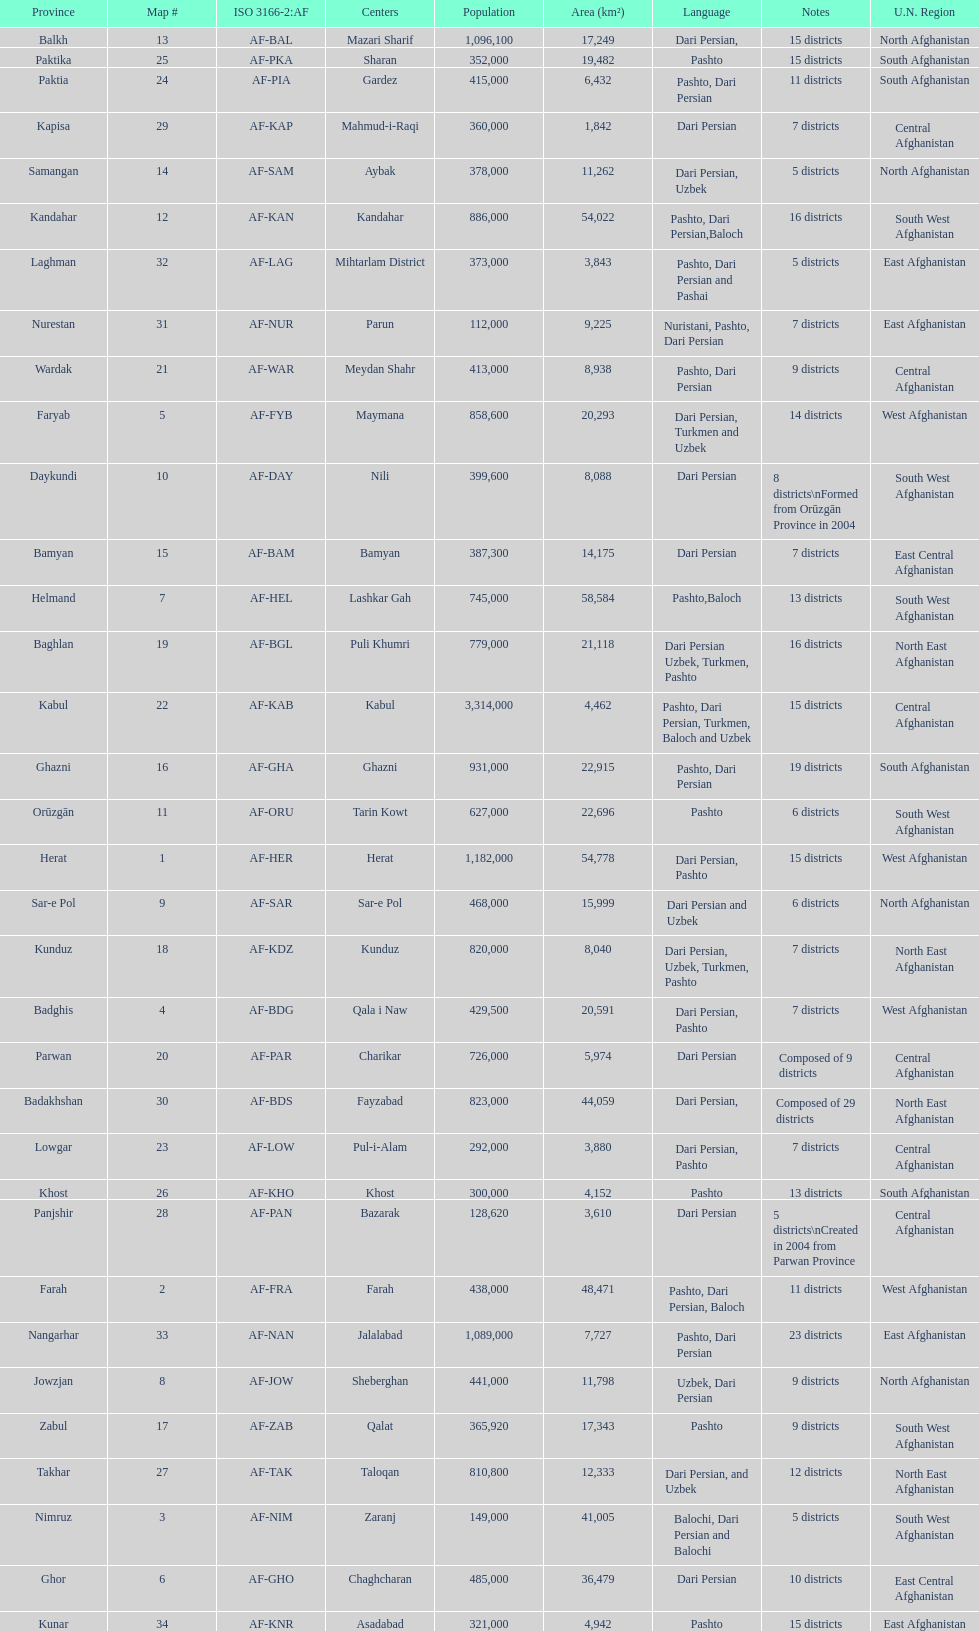Could you parse the entire table as a dict? {'header': ['Province', 'Map #', 'ISO 3166-2:AF', 'Centers', 'Population', 'Area (km²)', 'Language', 'Notes', 'U.N. Region'], 'rows': [['Balkh', '13', 'AF-BAL', 'Mazari Sharif', '1,096,100', '17,249', 'Dari Persian,', '15 districts', 'North Afghanistan'], ['Paktika', '25', 'AF-PKA', 'Sharan', '352,000', '19,482', 'Pashto', '15 districts', 'South Afghanistan'], ['Paktia', '24', 'AF-PIA', 'Gardez', '415,000', '6,432', 'Pashto, Dari Persian', '11 districts', 'South Afghanistan'], ['Kapisa', '29', 'AF-KAP', 'Mahmud-i-Raqi', '360,000', '1,842', 'Dari Persian', '7 districts', 'Central Afghanistan'], ['Samangan', '14', 'AF-SAM', 'Aybak', '378,000', '11,262', 'Dari Persian, Uzbek', '5 districts', 'North Afghanistan'], ['Kandahar', '12', 'AF-KAN', 'Kandahar', '886,000', '54,022', 'Pashto, Dari Persian,Baloch', '16 districts', 'South West Afghanistan'], ['Laghman', '32', 'AF-LAG', 'Mihtarlam District', '373,000', '3,843', 'Pashto, Dari Persian and Pashai', '5 districts', 'East Afghanistan'], ['Nurestan', '31', 'AF-NUR', 'Parun', '112,000', '9,225', 'Nuristani, Pashto, Dari Persian', '7 districts', 'East Afghanistan'], ['Wardak', '21', 'AF-WAR', 'Meydan Shahr', '413,000', '8,938', 'Pashto, Dari Persian', '9 districts', 'Central Afghanistan'], ['Faryab', '5', 'AF-FYB', 'Maymana', '858,600', '20,293', 'Dari Persian, Turkmen and Uzbek', '14 districts', 'West Afghanistan'], ['Daykundi', '10', 'AF-DAY', 'Nili', '399,600', '8,088', 'Dari Persian', '8 districts\\nFormed from Orūzgān Province in 2004', 'South West Afghanistan'], ['Bamyan', '15', 'AF-BAM', 'Bamyan', '387,300', '14,175', 'Dari Persian', '7 districts', 'East Central Afghanistan'], ['Helmand', '7', 'AF-HEL', 'Lashkar Gah', '745,000', '58,584', 'Pashto,Baloch', '13 districts', 'South West Afghanistan'], ['Baghlan', '19', 'AF-BGL', 'Puli Khumri', '779,000', '21,118', 'Dari Persian Uzbek, Turkmen, Pashto', '16 districts', 'North East Afghanistan'], ['Kabul', '22', 'AF-KAB', 'Kabul', '3,314,000', '4,462', 'Pashto, Dari Persian, Turkmen, Baloch and Uzbek', '15 districts', 'Central Afghanistan'], ['Ghazni', '16', 'AF-GHA', 'Ghazni', '931,000', '22,915', 'Pashto, Dari Persian', '19 districts', 'South Afghanistan'], ['Orūzgān', '11', 'AF-ORU', 'Tarin Kowt', '627,000', '22,696', 'Pashto', '6 districts', 'South West Afghanistan'], ['Herat', '1', 'AF-HER', 'Herat', '1,182,000', '54,778', 'Dari Persian, Pashto', '15 districts', 'West Afghanistan'], ['Sar-e Pol', '9', 'AF-SAR', 'Sar-e Pol', '468,000', '15,999', 'Dari Persian and Uzbek', '6 districts', 'North Afghanistan'], ['Kunduz', '18', 'AF-KDZ', 'Kunduz', '820,000', '8,040', 'Dari Persian, Uzbek, Turkmen, Pashto', '7 districts', 'North East Afghanistan'], ['Badghis', '4', 'AF-BDG', 'Qala i Naw', '429,500', '20,591', 'Dari Persian, Pashto', '7 districts', 'West Afghanistan'], ['Parwan', '20', 'AF-PAR', 'Charikar', '726,000', '5,974', 'Dari Persian', 'Composed of 9 districts', 'Central Afghanistan'], ['Badakhshan', '30', 'AF-BDS', 'Fayzabad', '823,000', '44,059', 'Dari Persian,', 'Composed of 29 districts', 'North East Afghanistan'], ['Lowgar', '23', 'AF-LOW', 'Pul-i-Alam', '292,000', '3,880', 'Dari Persian, Pashto', '7 districts', 'Central Afghanistan'], ['Khost', '26', 'AF-KHO', 'Khost', '300,000', '4,152', 'Pashto', '13 districts', 'South Afghanistan'], ['Panjshir', '28', 'AF-PAN', 'Bazarak', '128,620', '3,610', 'Dari Persian', '5 districts\\nCreated in 2004 from Parwan Province', 'Central Afghanistan'], ['Farah', '2', 'AF-FRA', 'Farah', '438,000', '48,471', 'Pashto, Dari Persian, Baloch', '11 districts', 'West Afghanistan'], ['Nangarhar', '33', 'AF-NAN', 'Jalalabad', '1,089,000', '7,727', 'Pashto, Dari Persian', '23 districts', 'East Afghanistan'], ['Jowzjan', '8', 'AF-JOW', 'Sheberghan', '441,000', '11,798', 'Uzbek, Dari Persian', '9 districts', 'North Afghanistan'], ['Zabul', '17', 'AF-ZAB', 'Qalat', '365,920', '17,343', 'Pashto', '9 districts', 'South West Afghanistan'], ['Takhar', '27', 'AF-TAK', 'Taloqan', '810,800', '12,333', 'Dari Persian, and Uzbek', '12 districts', 'North East Afghanistan'], ['Nimruz', '3', 'AF-NIM', 'Zaranj', '149,000', '41,005', 'Balochi, Dari Persian and Balochi', '5 districts', 'South West Afghanistan'], ['Ghor', '6', 'AF-GHO', 'Chaghcharan', '485,000', '36,479', 'Dari Persian', '10 districts', 'East Central Afghanistan'], ['Kunar', '34', 'AF-KNR', 'Asadabad', '321,000', '4,942', 'Pashto', '15 districts', 'East Afghanistan']]} What province in afghanistanhas the greatest population? Kabul. 